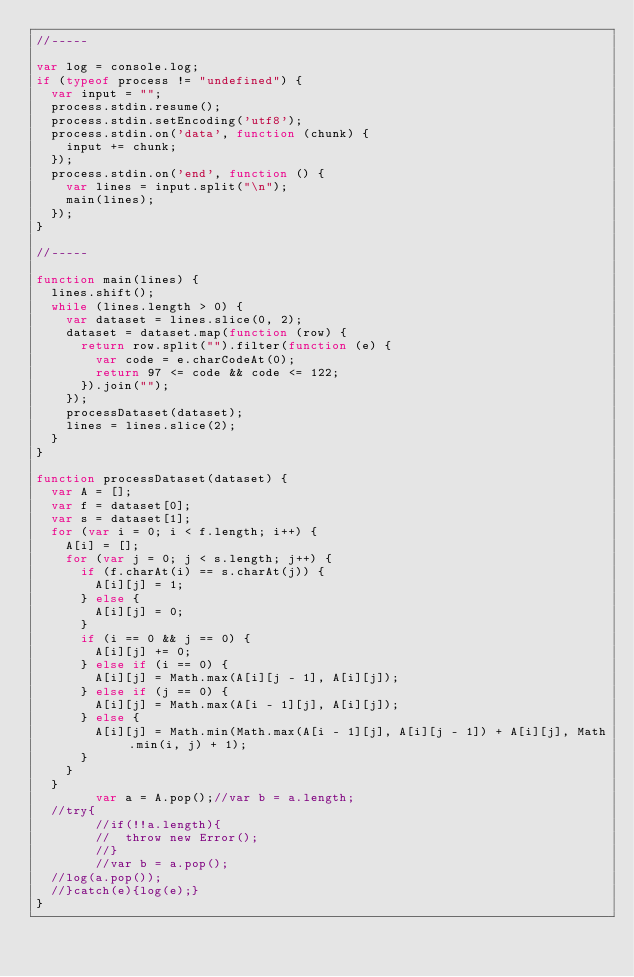<code> <loc_0><loc_0><loc_500><loc_500><_JavaScript_>//-----

var log = console.log;
if (typeof process != "undefined") {
	var input = "";
	process.stdin.resume();
	process.stdin.setEncoding('utf8');
	process.stdin.on('data', function (chunk) {
		input += chunk;
	});
	process.stdin.on('end', function () {
		var lines = input.split("\n");
		main(lines);
	});
}

//-----

function main(lines) {
	lines.shift();
	while (lines.length > 0) {
		var dataset = lines.slice(0, 2);
		dataset = dataset.map(function (row) {
			return row.split("").filter(function (e) {
				var code = e.charCodeAt(0);
				return 97 <= code && code <= 122;
			}).join("");
		});
		processDataset(dataset);
		lines = lines.slice(2);
	}
}

function processDataset(dataset) {
	var A = [];
	var f = dataset[0];
	var s = dataset[1];
	for (var i = 0; i < f.length; i++) {
		A[i] = [];
		for (var j = 0; j < s.length; j++) {
			if (f.charAt(i) == s.charAt(j)) {
				A[i][j] = 1;
			} else {
				A[i][j] = 0;
			}
			if (i == 0 && j == 0) {
				A[i][j] += 0;
			} else if (i == 0) {
				A[i][j] = Math.max(A[i][j - 1], A[i][j]);
			} else if (j == 0) {
				A[i][j] = Math.max(A[i - 1][j], A[i][j]);
			} else {
				A[i][j] = Math.min(Math.max(A[i - 1][j], A[i][j - 1]) + A[i][j], Math.min(i, j) + 1);
			}
		}
	}
        var a = A.pop();//var b = a.length;
	//try{
        //if(!!a.length){
        //  throw new Error();
        //}
        //var b = a.pop();
	//log(a.pop());
	//}catch(e){log(e);}
}</code> 